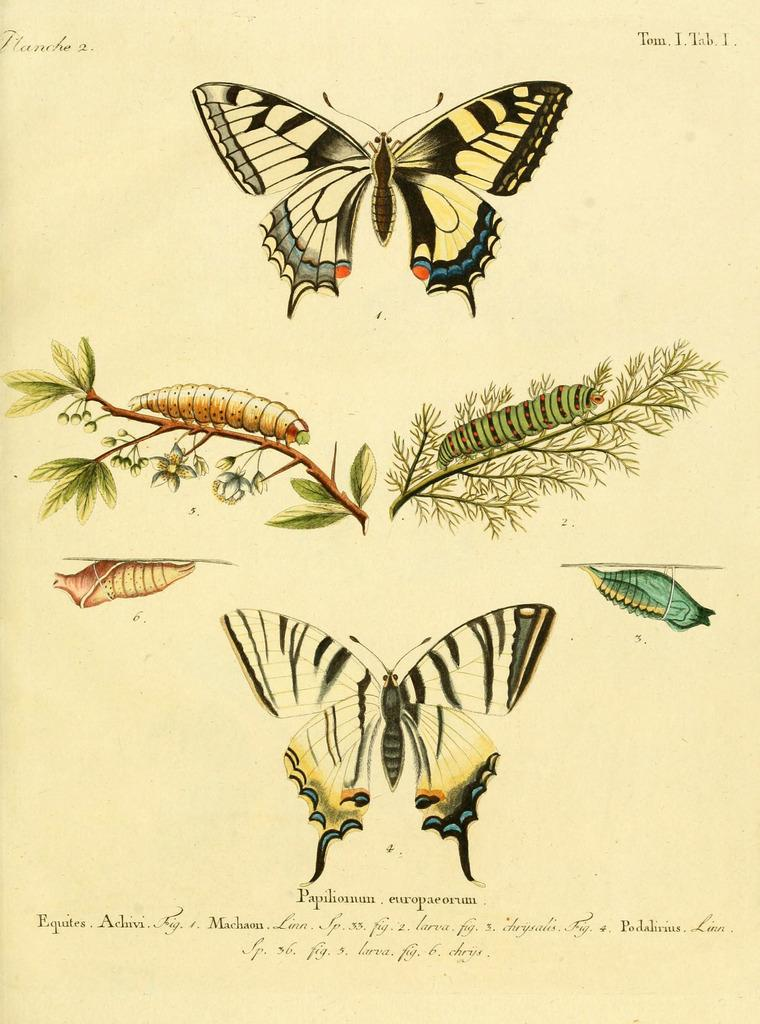What type of insects can be seen in the drawings of the image? There are drawings of butterflies and caterpillars in the image. What is written at the bottom of the image? There is text written at the bottom of the image. What type of wine is being served in the image? There is no wine present in the image; it features drawings of butterflies and caterpillars, along with text at the bottom. How many crows are visible in the image? There are no crows present in the image. 